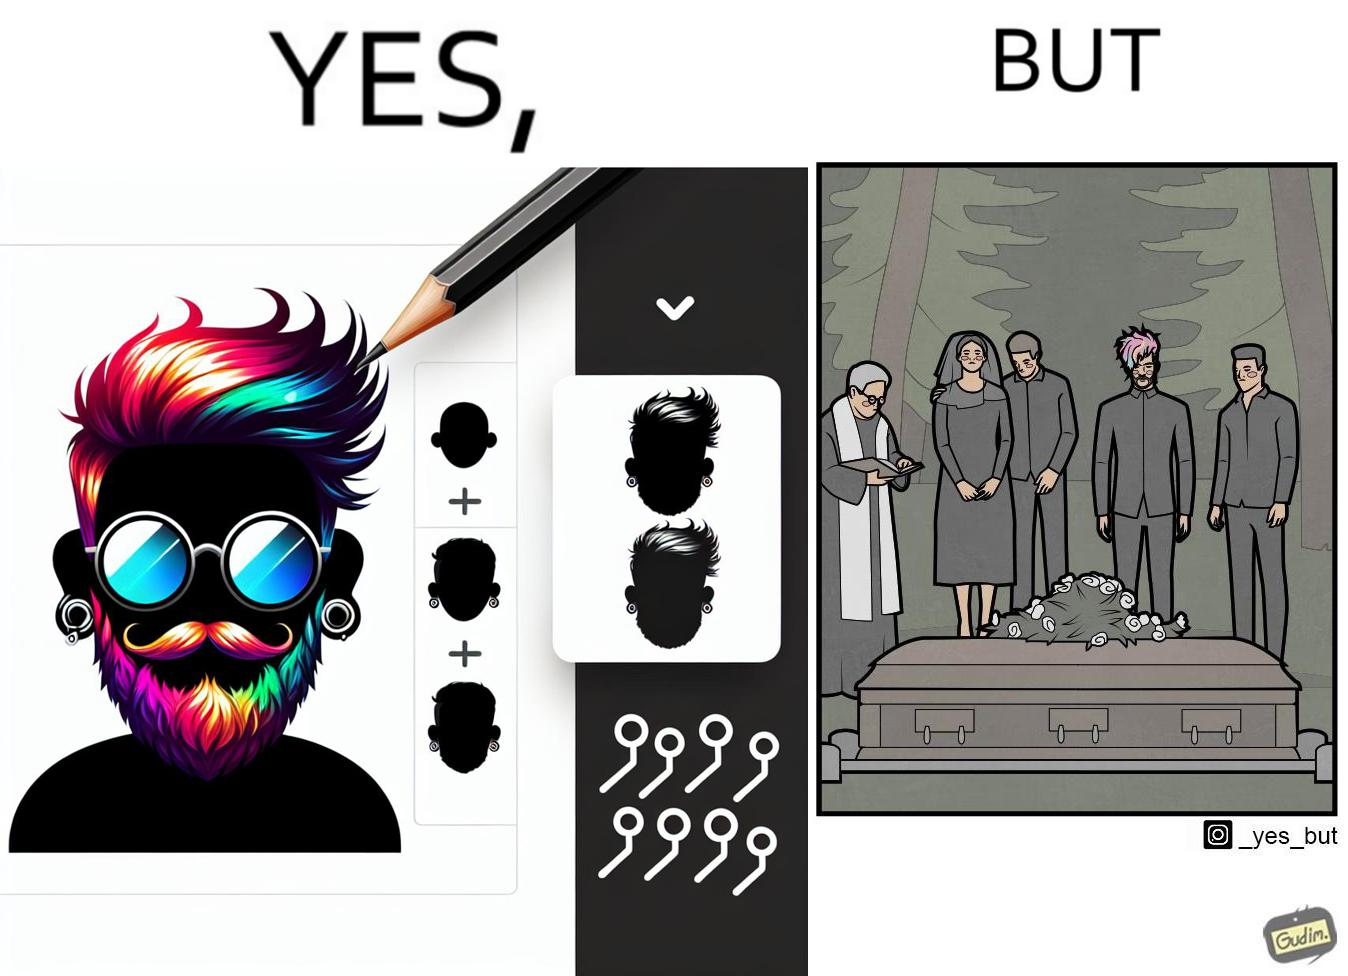What is shown in the left half versus the right half of this image? In the left part of the image: a person with colorful hairstyle, stylish beard at ear piercings In the right part of the image: a group of persons at the death ceremony of some person performing the last rituals 